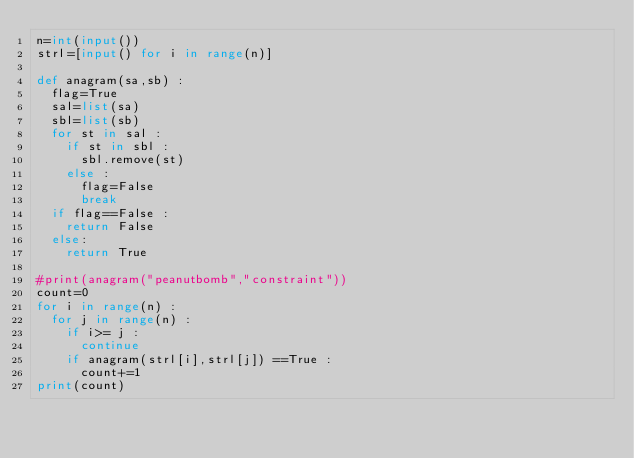Convert code to text. <code><loc_0><loc_0><loc_500><loc_500><_Python_>n=int(input())
strl=[input() for i in range(n)]

def anagram(sa,sb) :
  flag=True
  sal=list(sa)
  sbl=list(sb)
  for st in sal :
    if st in sbl :
      sbl.remove(st)
    else :
      flag=False
      break
  if flag==False :
    return False
  else:
    return True
   
#print(anagram("peanutbomb","constraint"))    
count=0
for i in range(n) :
  for j in range(n) :
    if i>= j :
      continue
    if anagram(strl[i],strl[j]) ==True :
      count+=1
print(count)</code> 